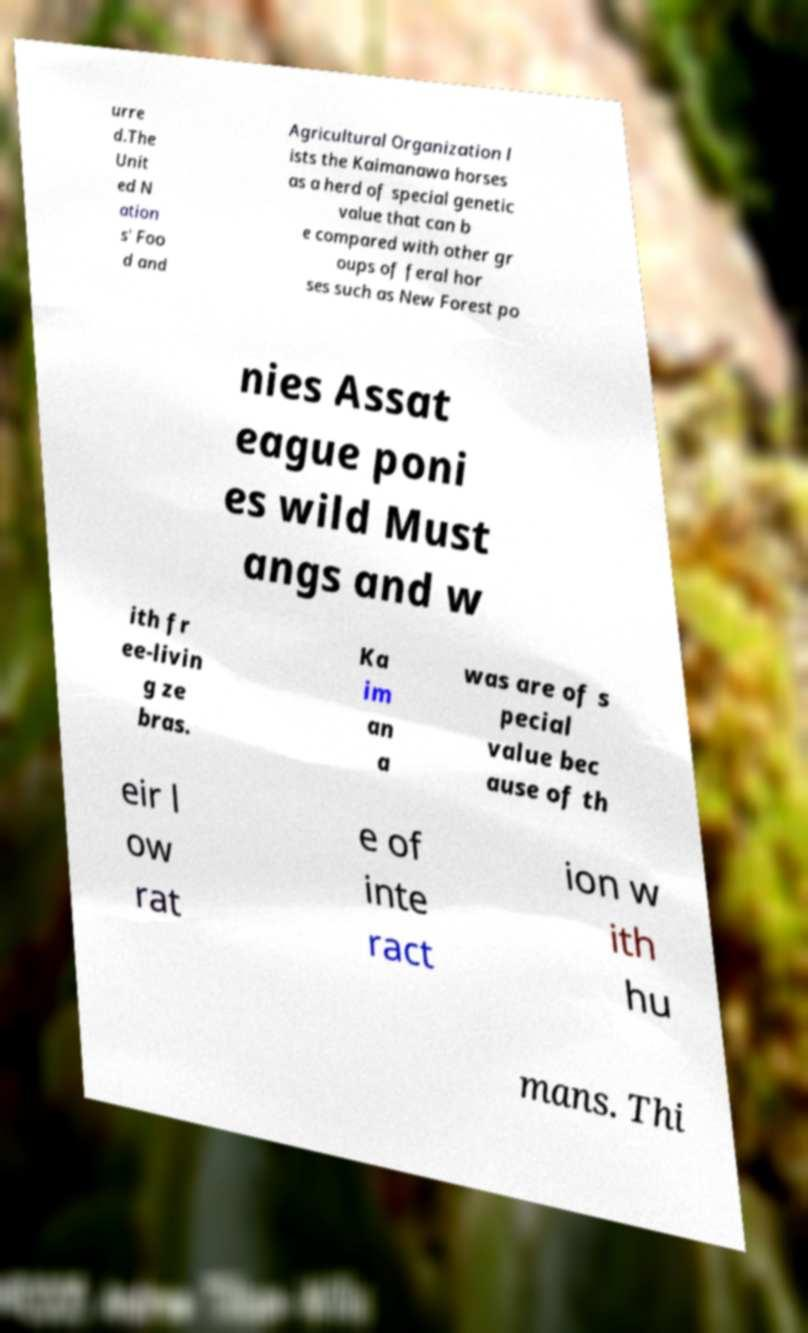For documentation purposes, I need the text within this image transcribed. Could you provide that? urre d.The Unit ed N ation s' Foo d and Agricultural Organization l ists the Kaimanawa horses as a herd of special genetic value that can b e compared with other gr oups of feral hor ses such as New Forest po nies Assat eague poni es wild Must angs and w ith fr ee-livin g ze bras. Ka im an a was are of s pecial value bec ause of th eir l ow rat e of inte ract ion w ith hu mans. Thi 